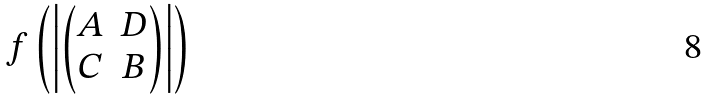Convert formula to latex. <formula><loc_0><loc_0><loc_500><loc_500>f \left ( \left | \begin{pmatrix} A & D \\ C & B \end{pmatrix} \right | \right )</formula> 